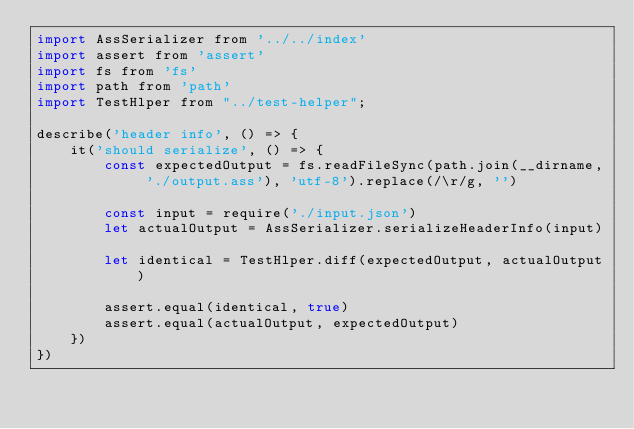Convert code to text. <code><loc_0><loc_0><loc_500><loc_500><_JavaScript_>import AssSerializer from '../../index'
import assert from 'assert'
import fs from 'fs'
import path from 'path'
import TestHlper from "../test-helper";

describe('header info', () => {
    it('should serialize', () => {
        const expectedOutput = fs.readFileSync(path.join(__dirname, './output.ass'), 'utf-8').replace(/\r/g, '')

        const input = require('./input.json')
        let actualOutput = AssSerializer.serializeHeaderInfo(input)

        let identical = TestHlper.diff(expectedOutput, actualOutput)

        assert.equal(identical, true)
        assert.equal(actualOutput, expectedOutput)
    })
})
</code> 